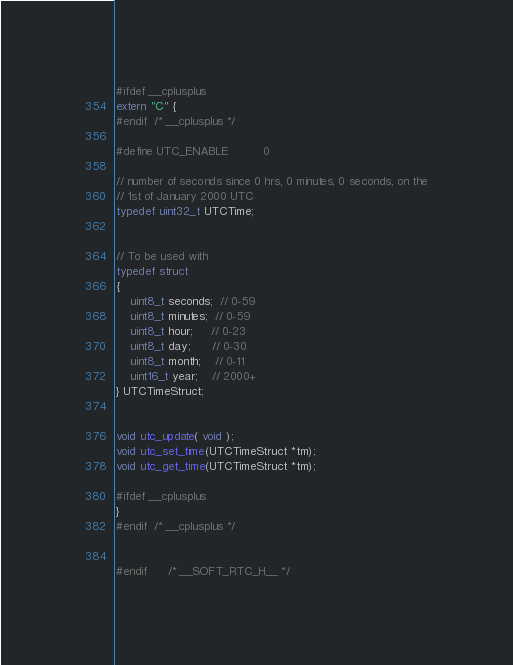Convert code to text. <code><loc_0><loc_0><loc_500><loc_500><_C_>

#ifdef __cplusplus
extern "C" {
#endif  /* __cplusplus */

#define UTC_ENABLE          0

// number of seconds since 0 hrs, 0 minutes, 0 seconds, on the
// 1st of January 2000 UTC
typedef uint32_t UTCTime;


// To be used with
typedef struct
{
    uint8_t seconds;  // 0-59
    uint8_t minutes;  // 0-59
    uint8_t hour;     // 0-23
    uint8_t day;      // 0-30
    uint8_t month;    // 0-11
    uint16_t year;    // 2000+
} UTCTimeStruct;


void utc_update( void );
void utc_set_time(UTCTimeStruct *tm);
void utc_get_time(UTCTimeStruct *tm);

#ifdef __cplusplus
}
#endif  /* __cplusplus */


#endif      /* __SOFT_RTC_H__ */

</code> 